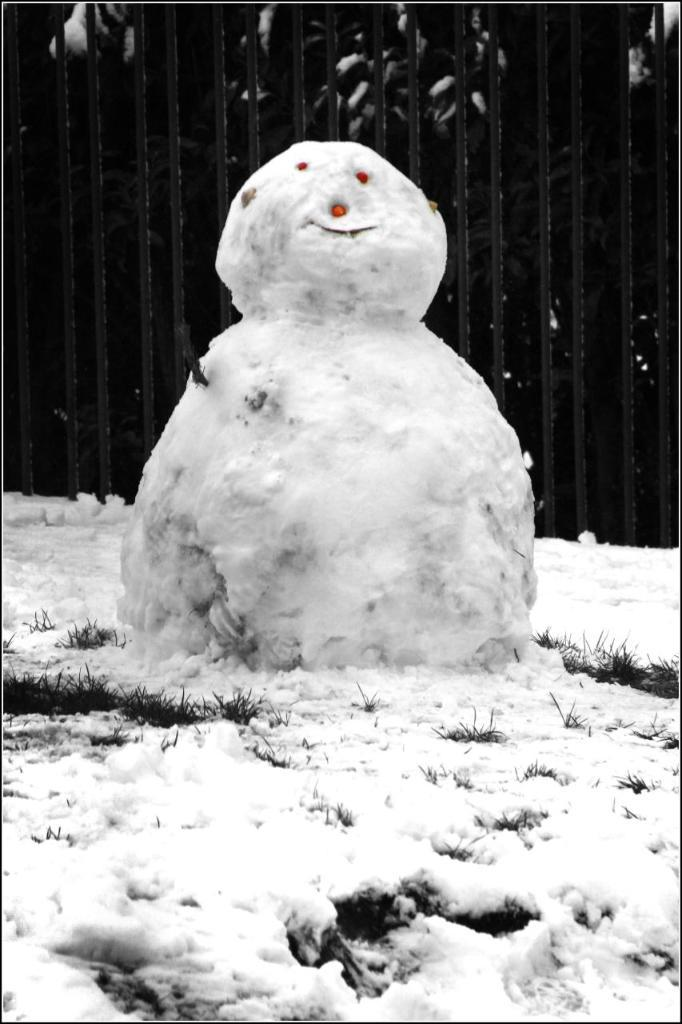What is the main subject in the image? There is a snowman in the image. What is the snowman standing in front of? The snowman is in front of rods. Is there a slope visible in the image? There is no slope present in the image. Is there a tent visible in the image? There is no tent present in the image. Is there a tub visible in the image? There is no tub present in the image. 